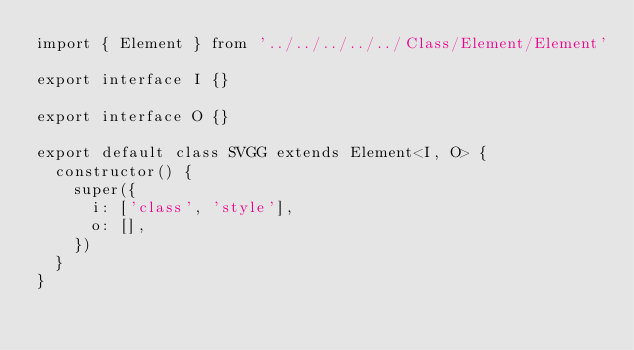Convert code to text. <code><loc_0><loc_0><loc_500><loc_500><_TypeScript_>import { Element } from '../../../../../Class/Element/Element'

export interface I {}

export interface O {}

export default class SVGG extends Element<I, O> {
  constructor() {
    super({
      i: ['class', 'style'],
      o: [],
    })
  }
}
</code> 